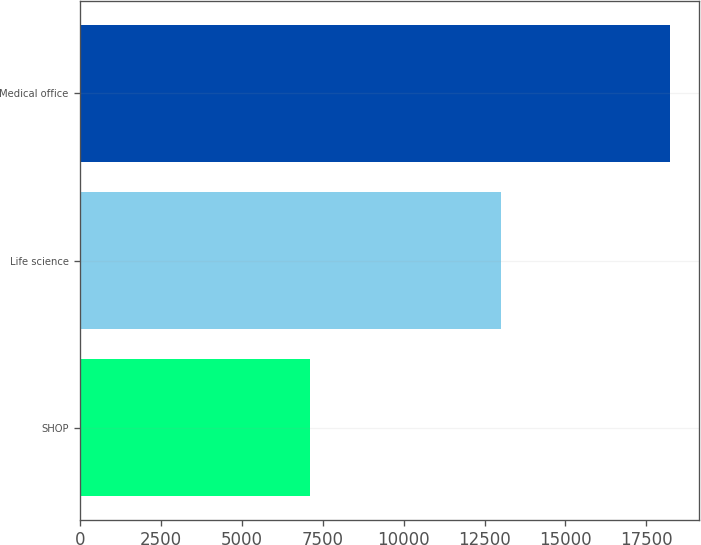Convert chart to OTSL. <chart><loc_0><loc_0><loc_500><loc_500><bar_chart><fcel>SHOP<fcel>Life science<fcel>Medical office<nl><fcel>7115<fcel>13019<fcel>18229<nl></chart> 